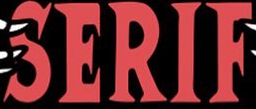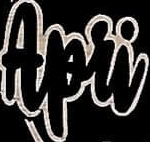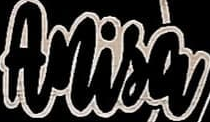Read the text content from these images in order, separated by a semicolon. SERIF; Apri; Anisa 